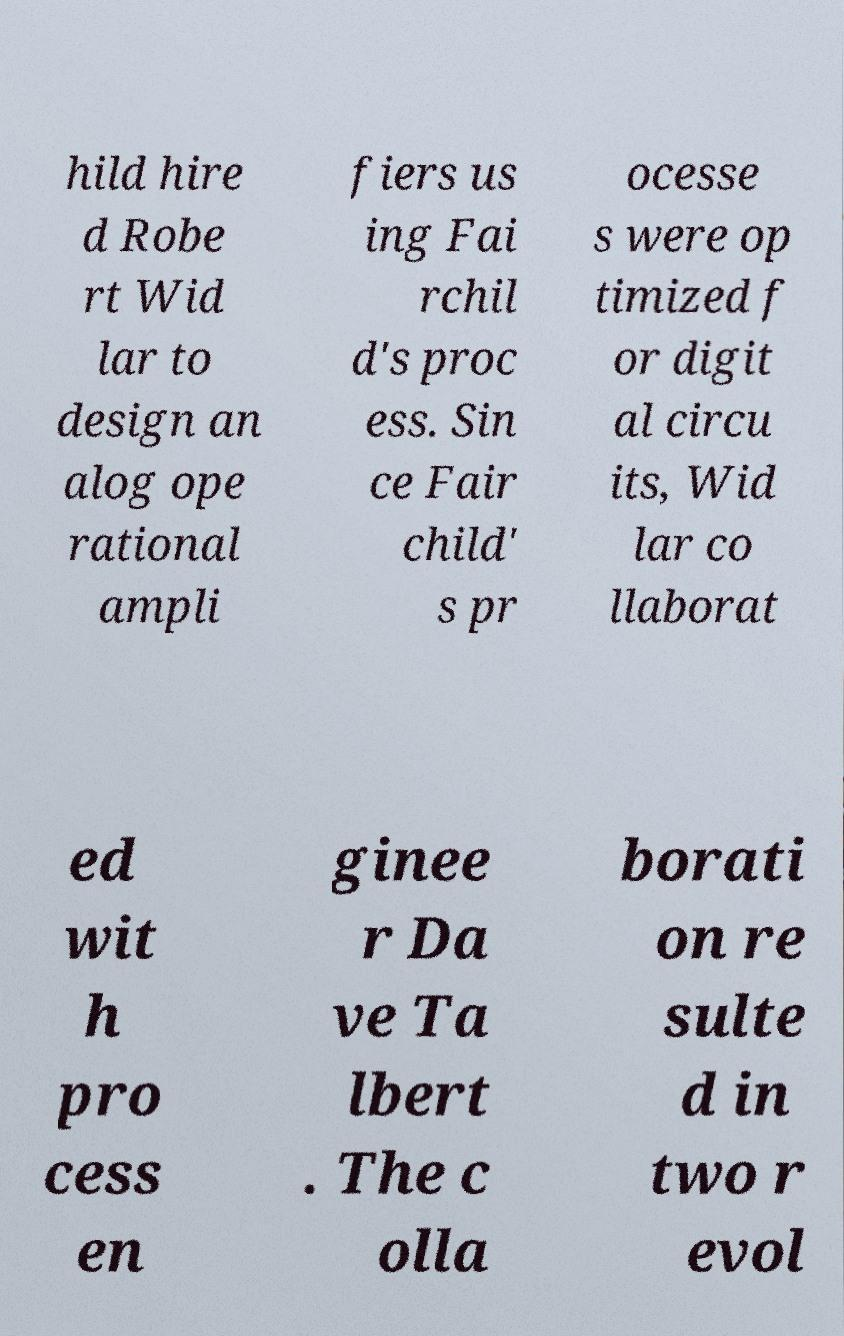For documentation purposes, I need the text within this image transcribed. Could you provide that? hild hire d Robe rt Wid lar to design an alog ope rational ampli fiers us ing Fai rchil d's proc ess. Sin ce Fair child' s pr ocesse s were op timized f or digit al circu its, Wid lar co llaborat ed wit h pro cess en ginee r Da ve Ta lbert . The c olla borati on re sulte d in two r evol 